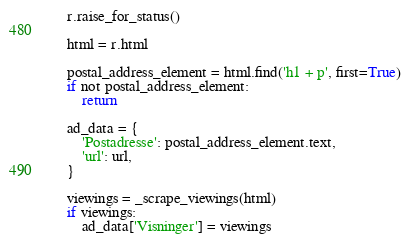Convert code to text. <code><loc_0><loc_0><loc_500><loc_500><_Python_>    r.raise_for_status()

    html = r.html

    postal_address_element = html.find('h1 + p', first=True)
    if not postal_address_element:
        return

    ad_data = {
        'Postadresse': postal_address_element.text,
        'url': url,
    }

    viewings = _scrape_viewings(html)
    if viewings:
        ad_data['Visninger'] = viewings</code> 